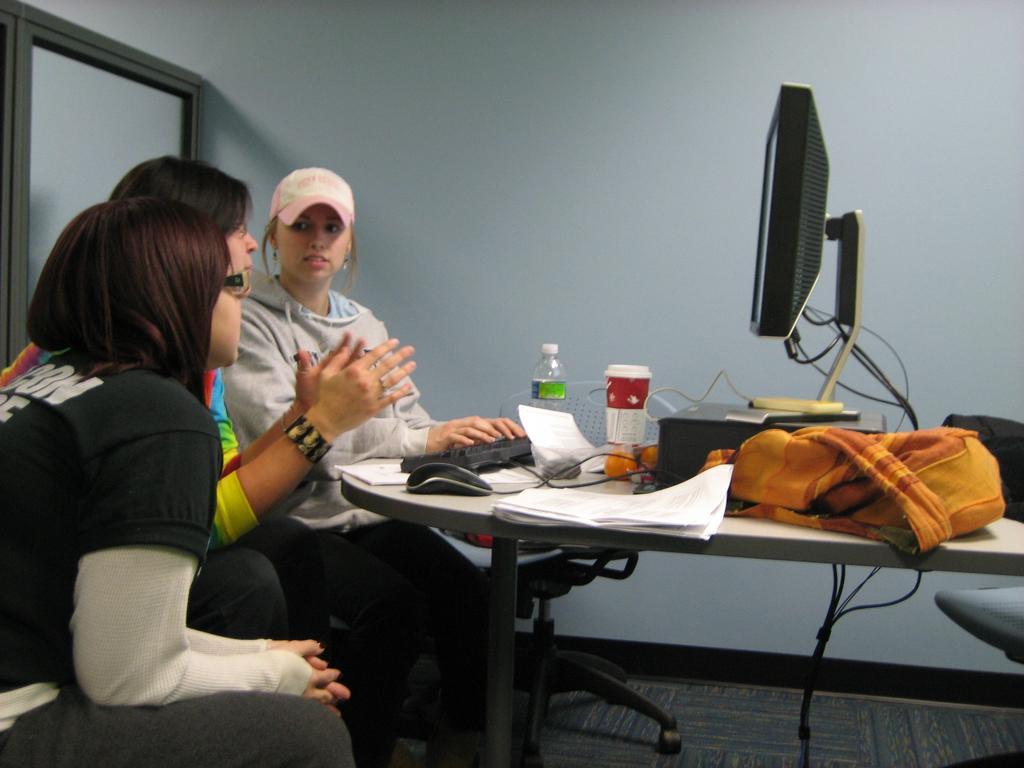Can you describe this image briefly? People are sitting on chair near the table and on the table there is monitor,bottle,glass,paper,bag. 